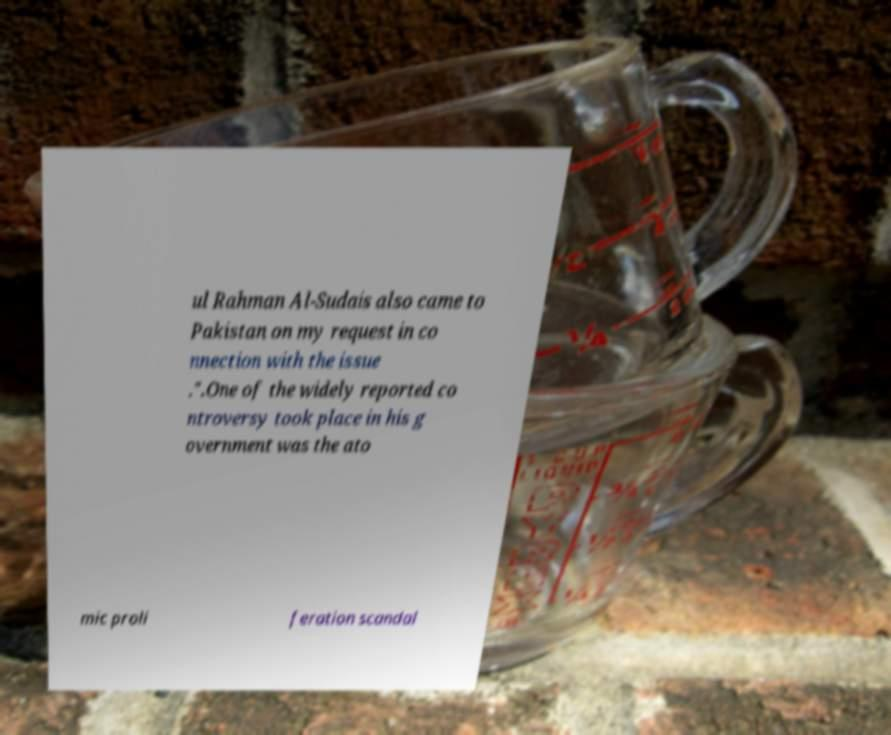Can you read and provide the text displayed in the image?This photo seems to have some interesting text. Can you extract and type it out for me? ul Rahman Al-Sudais also came to Pakistan on my request in co nnection with the issue .".One of the widely reported co ntroversy took place in his g overnment was the ato mic proli feration scandal 